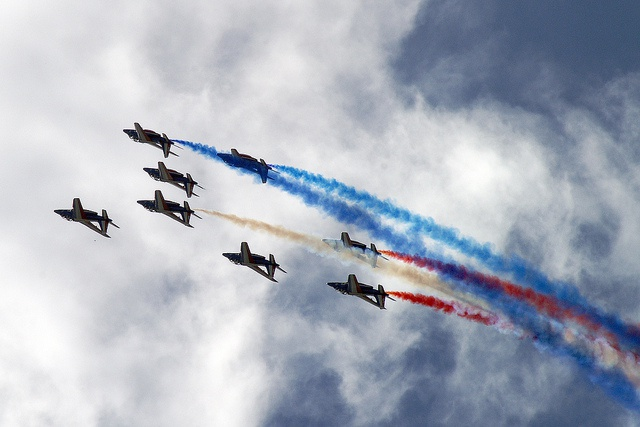Describe the objects in this image and their specific colors. I can see airplane in white, black, gray, darkgray, and lightgray tones, airplane in white, black, gray, lightgray, and darkgray tones, airplane in white, darkgray, black, and gray tones, airplane in white, black, gray, and lightgray tones, and airplane in white, black, and gray tones in this image. 